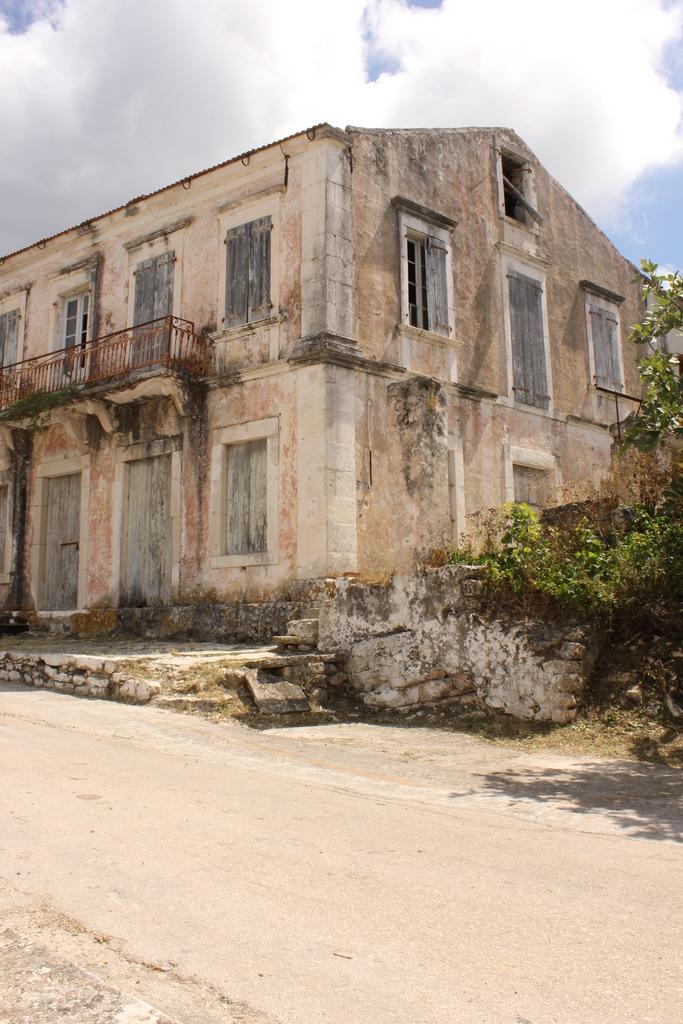Can you describe this image briefly? In this image there is an old building in the middle. At the top there is the sky. At the bottom there is a road. On the right side there is a tree. 